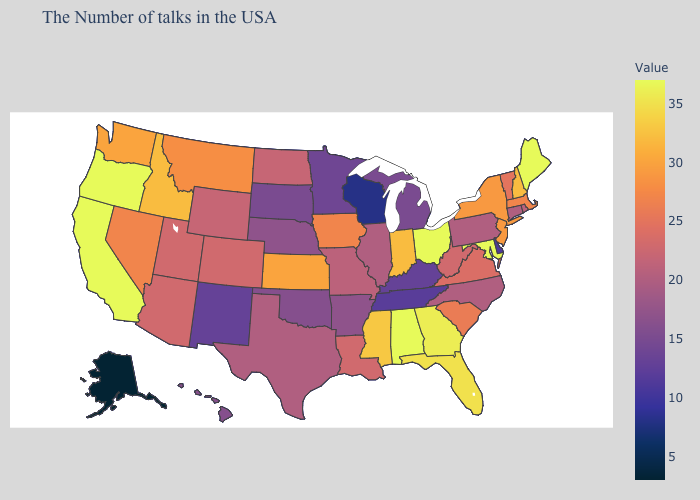Among the states that border Kentucky , which have the lowest value?
Give a very brief answer. Tennessee. Among the states that border New York , does Vermont have the lowest value?
Quick response, please. No. Does North Carolina have the lowest value in the South?
Be succinct. No. Which states have the highest value in the USA?
Concise answer only. Maine, Maryland, Ohio, Alabama, California, Oregon. Which states have the highest value in the USA?
Be succinct. Maine, Maryland, Ohio, Alabama, California, Oregon. Which states have the highest value in the USA?
Write a very short answer. Maine, Maryland, Ohio, Alabama, California, Oregon. Does Maine have the highest value in the Northeast?
Short answer required. Yes. 